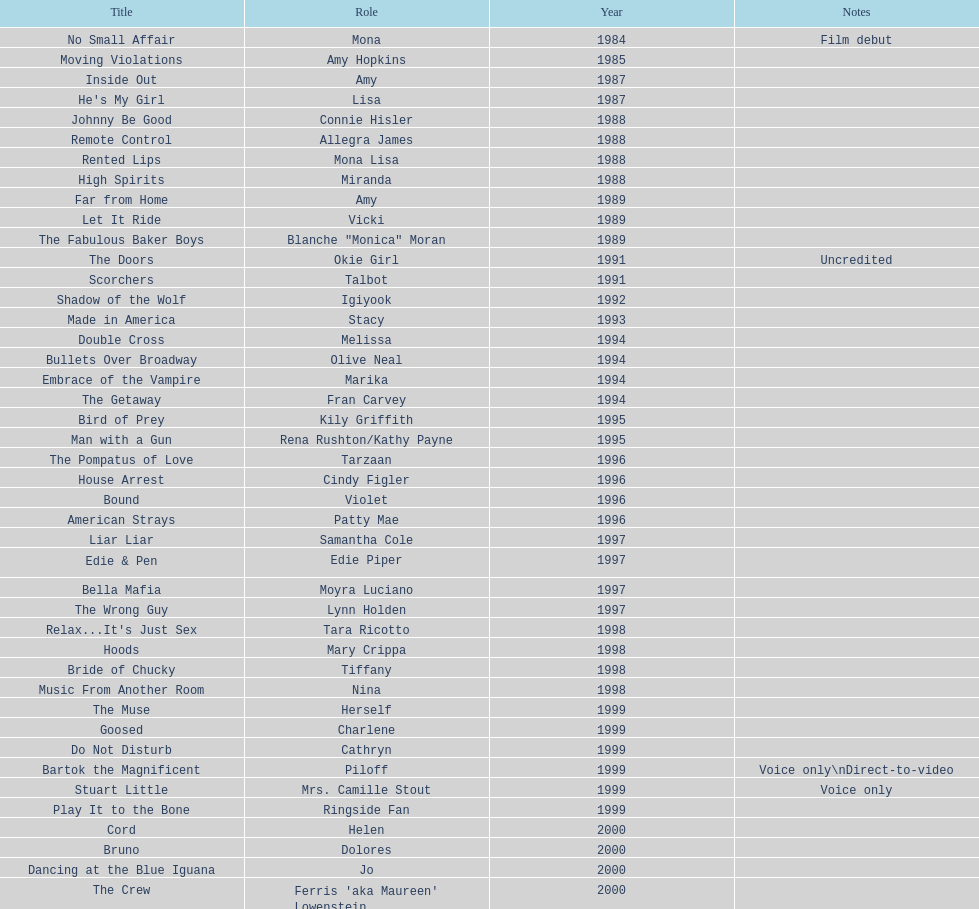How many rolls did jennifer tilly play in the 1980s? 11. 